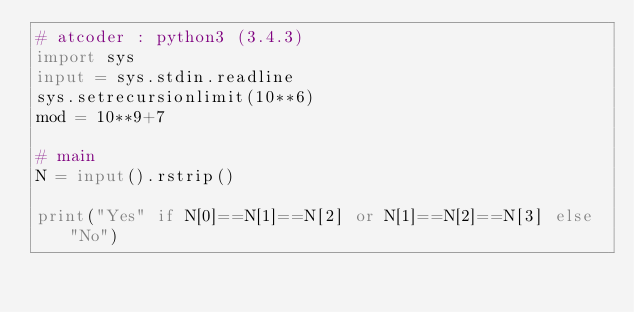Convert code to text. <code><loc_0><loc_0><loc_500><loc_500><_Python_># atcoder : python3 (3.4.3)
import sys
input = sys.stdin.readline
sys.setrecursionlimit(10**6)
mod = 10**9+7

# main
N = input().rstrip()

print("Yes" if N[0]==N[1]==N[2] or N[1]==N[2]==N[3] else "No")</code> 